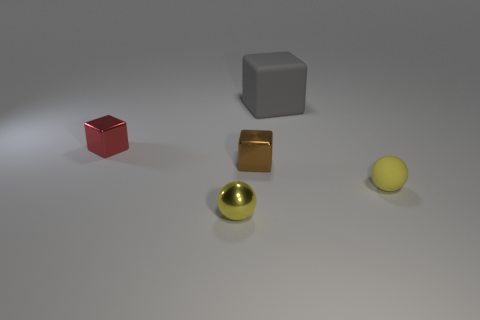Subtract 1 blocks. How many blocks are left? 2 Add 1 green objects. How many objects exist? 6 Subtract all balls. How many objects are left? 3 Add 1 big gray matte cubes. How many big gray matte cubes exist? 2 Subtract 1 brown blocks. How many objects are left? 4 Subtract all tiny green metallic blocks. Subtract all big gray matte cubes. How many objects are left? 4 Add 4 big blocks. How many big blocks are left? 5 